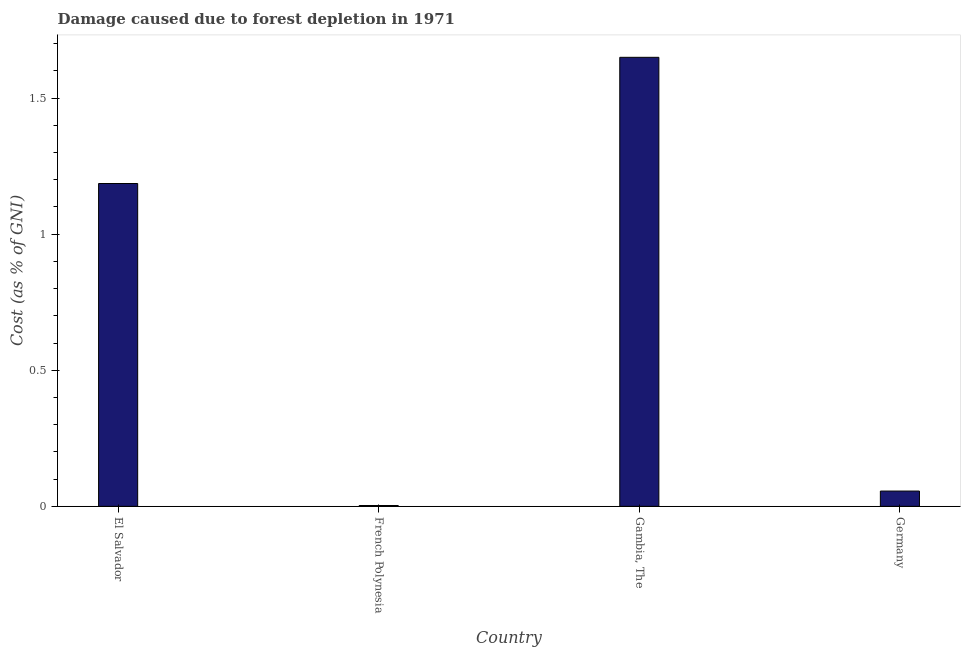What is the title of the graph?
Your answer should be very brief. Damage caused due to forest depletion in 1971. What is the label or title of the Y-axis?
Make the answer very short. Cost (as % of GNI). What is the damage caused due to forest depletion in Germany?
Your answer should be very brief. 0.06. Across all countries, what is the maximum damage caused due to forest depletion?
Keep it short and to the point. 1.65. Across all countries, what is the minimum damage caused due to forest depletion?
Your response must be concise. 0. In which country was the damage caused due to forest depletion maximum?
Provide a succinct answer. Gambia, The. In which country was the damage caused due to forest depletion minimum?
Offer a very short reply. French Polynesia. What is the sum of the damage caused due to forest depletion?
Your answer should be very brief. 2.89. What is the difference between the damage caused due to forest depletion in French Polynesia and Germany?
Your answer should be compact. -0.05. What is the average damage caused due to forest depletion per country?
Your answer should be very brief. 0.72. What is the median damage caused due to forest depletion?
Provide a succinct answer. 0.62. What is the ratio of the damage caused due to forest depletion in El Salvador to that in Germany?
Ensure brevity in your answer.  21.12. Is the difference between the damage caused due to forest depletion in Gambia, The and Germany greater than the difference between any two countries?
Offer a terse response. No. What is the difference between the highest and the second highest damage caused due to forest depletion?
Offer a terse response. 0.46. What is the difference between the highest and the lowest damage caused due to forest depletion?
Make the answer very short. 1.65. How many bars are there?
Your answer should be compact. 4. What is the Cost (as % of GNI) in El Salvador?
Provide a succinct answer. 1.19. What is the Cost (as % of GNI) of French Polynesia?
Your response must be concise. 0. What is the Cost (as % of GNI) of Gambia, The?
Ensure brevity in your answer.  1.65. What is the Cost (as % of GNI) in Germany?
Your answer should be very brief. 0.06. What is the difference between the Cost (as % of GNI) in El Salvador and French Polynesia?
Your answer should be compact. 1.18. What is the difference between the Cost (as % of GNI) in El Salvador and Gambia, The?
Your answer should be compact. -0.46. What is the difference between the Cost (as % of GNI) in El Salvador and Germany?
Your answer should be very brief. 1.13. What is the difference between the Cost (as % of GNI) in French Polynesia and Gambia, The?
Provide a short and direct response. -1.65. What is the difference between the Cost (as % of GNI) in French Polynesia and Germany?
Your answer should be very brief. -0.05. What is the difference between the Cost (as % of GNI) in Gambia, The and Germany?
Offer a very short reply. 1.59. What is the ratio of the Cost (as % of GNI) in El Salvador to that in French Polynesia?
Make the answer very short. 388.21. What is the ratio of the Cost (as % of GNI) in El Salvador to that in Gambia, The?
Make the answer very short. 0.72. What is the ratio of the Cost (as % of GNI) in El Salvador to that in Germany?
Offer a terse response. 21.12. What is the ratio of the Cost (as % of GNI) in French Polynesia to that in Gambia, The?
Provide a short and direct response. 0. What is the ratio of the Cost (as % of GNI) in French Polynesia to that in Germany?
Offer a terse response. 0.05. What is the ratio of the Cost (as % of GNI) in Gambia, The to that in Germany?
Provide a short and direct response. 29.38. 